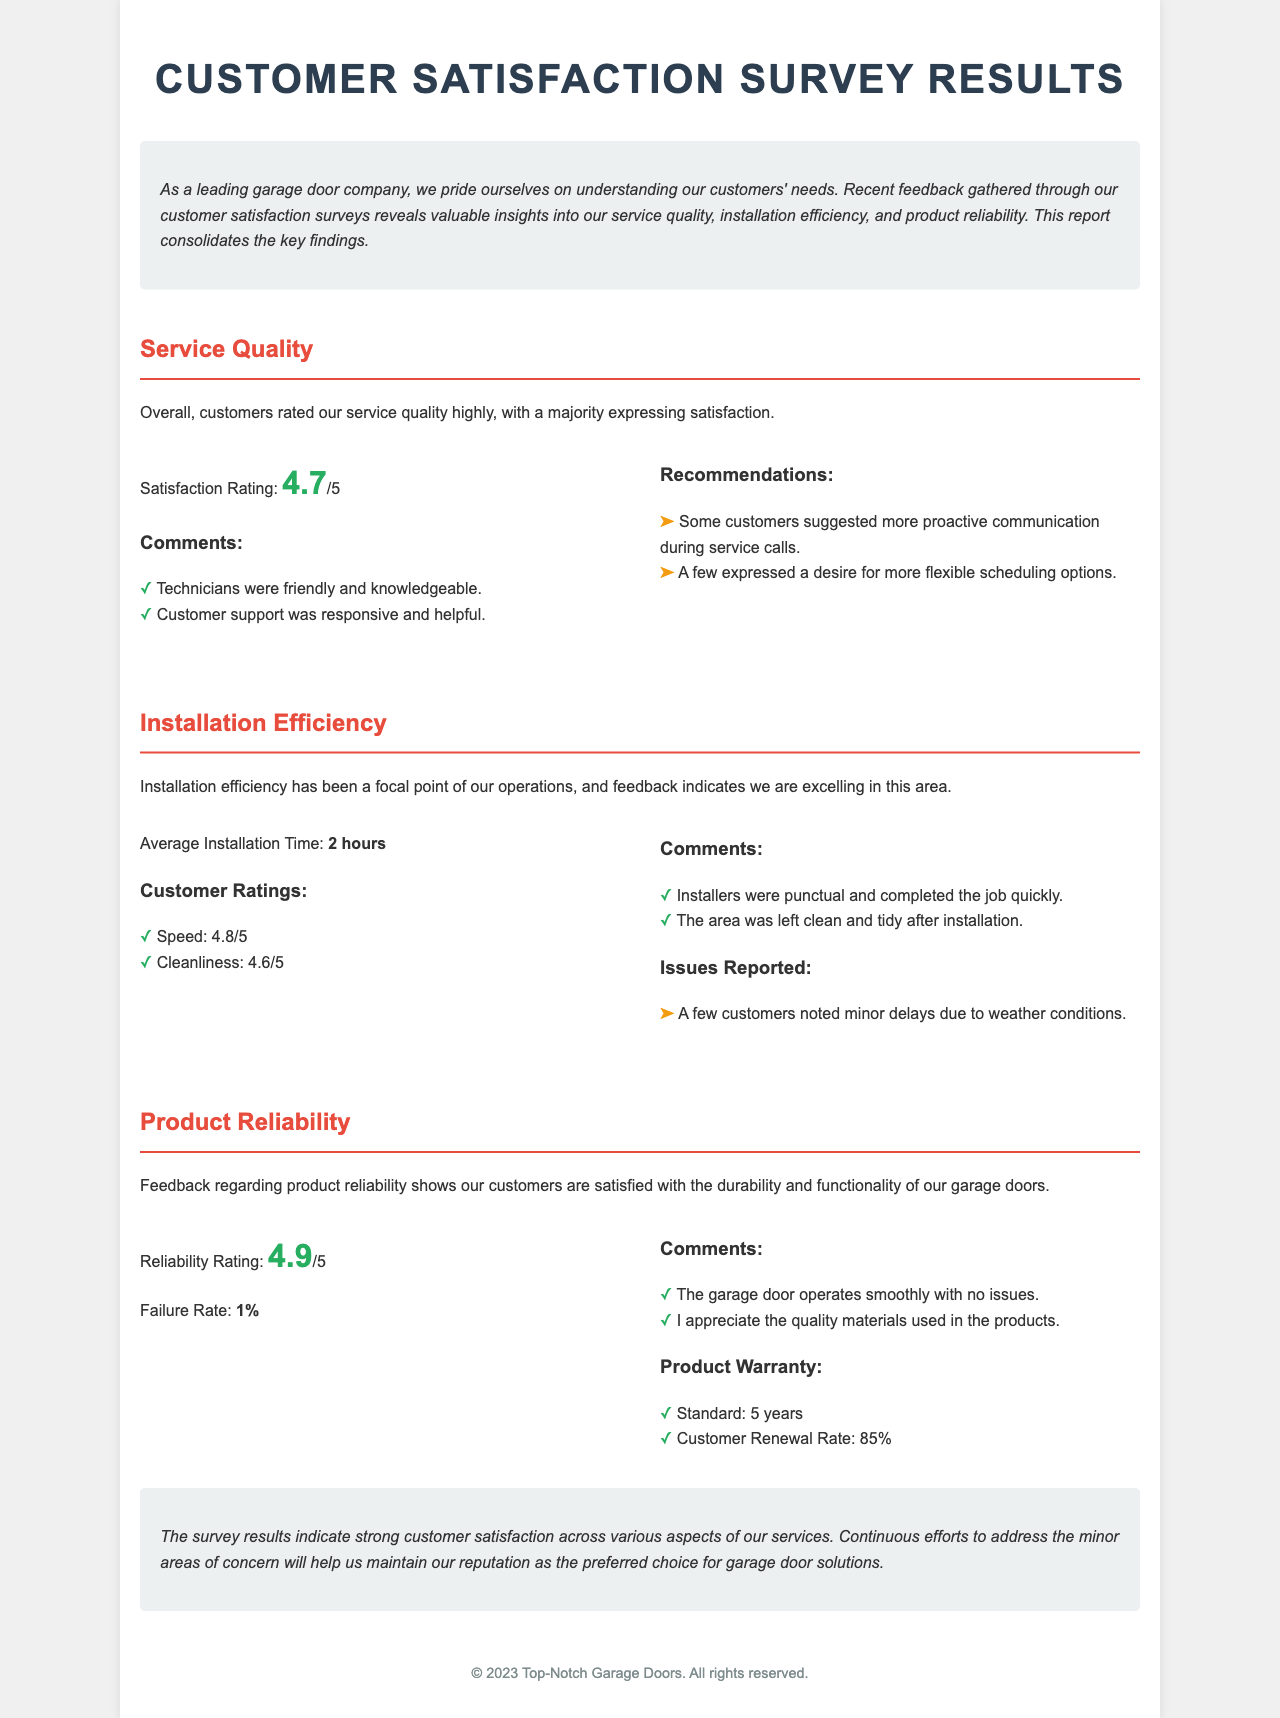What is the satisfaction rating for service quality? The satisfaction rating for service quality is explicitly mentioned in the document under the Service Quality section.
Answer: 4.7/5 What is the average installation time? The average installation time is listed in the Installation Efficiency section of the document.
Answer: 2 hours What is the reliability rating of the product? The reliability rating is found in the Product Reliability section and reflects customer satisfaction with product durability.
Answer: 4.9/5 What percentage of customers renewed their product warranty? The document provides the customer renewal rate for the product warranty, which is included in the Product Reliability section.
Answer: 85% What issue was reported by customers regarding installation? The document mentions specific issues reported by customers in the Installation Efficiency section, which required reasoning to identify the details outlined.
Answer: Minor delays due to weather conditions How do customers rate the speed of installation? The speed rating for installation is indicated under the customer ratings in the Installation Efficiency section, which requires being attentive to details in that context.
Answer: 4.8/5 What additional recommendation did customers make about service? The recommendations made by customers regarding service quality are found in the Service Quality section and summarize customer suggestions.
Answer: More proactive communication What was mentioned about customer support? Customer comments about support can be found in the Service Quality section, where feedback about specific staff performance is discussed.
Answer: Responsive and helpful 